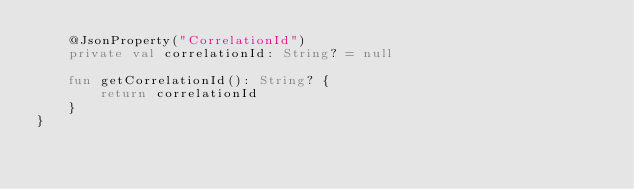Convert code to text. <code><loc_0><loc_0><loc_500><loc_500><_Kotlin_>    @JsonProperty("CorrelationId")
    private val correlationId: String? = null

    fun getCorrelationId(): String? {
        return correlationId
    }
}
</code> 